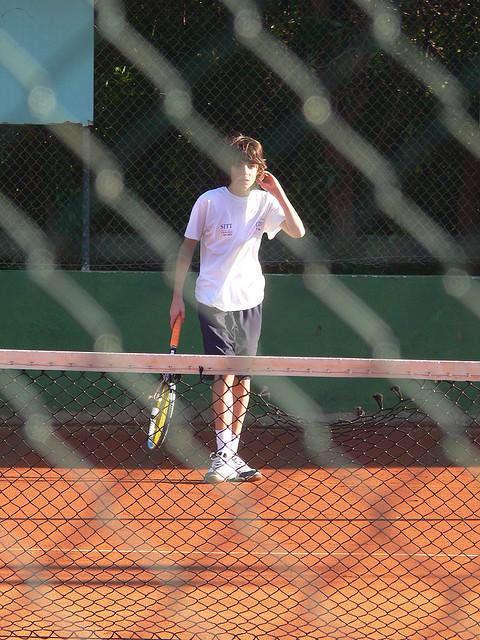Is the ball in the air?
Short answer required. No. Does this guy need a haircut?
Keep it brief. Yes. Is this man serving a tennis ball?
Give a very brief answer. No. Is it night time in the picture?
Answer briefly. No. 